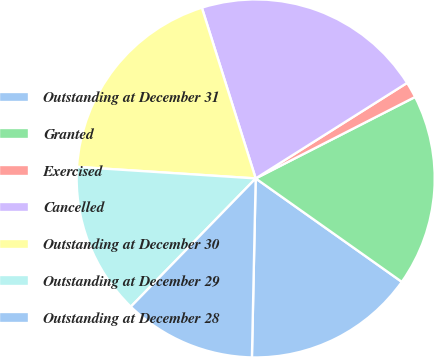Convert chart to OTSL. <chart><loc_0><loc_0><loc_500><loc_500><pie_chart><fcel>Outstanding at December 31<fcel>Granted<fcel>Exercised<fcel>Cancelled<fcel>Outstanding at December 30<fcel>Outstanding at December 29<fcel>Outstanding at December 28<nl><fcel>15.53%<fcel>17.32%<fcel>1.44%<fcel>20.9%<fcel>19.11%<fcel>13.74%<fcel>11.95%<nl></chart> 